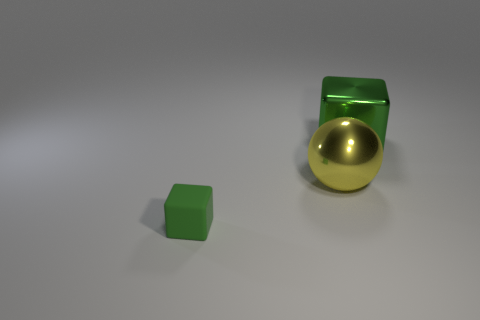There is a tiny matte object; is its color the same as the block right of the small block?
Keep it short and to the point. Yes. Is the color of the cube that is right of the small green rubber thing the same as the tiny matte object?
Make the answer very short. Yes. Are there more tiny objects than blocks?
Your response must be concise. No. Does the big yellow ball have the same material as the big block?
Provide a short and direct response. Yes. Is there any other thing that has the same material as the small thing?
Your answer should be compact. No. Is the number of tiny rubber objects that are in front of the big green object greater than the number of tiny blue metallic cylinders?
Ensure brevity in your answer.  Yes. Is the tiny thing the same color as the large shiny block?
Your response must be concise. Yes. What number of large metallic objects have the same shape as the small matte thing?
Ensure brevity in your answer.  1. What size is the green block that is the same material as the ball?
Keep it short and to the point. Large. There is a object that is left of the big green metallic cube and on the right side of the tiny green rubber object; what is its color?
Ensure brevity in your answer.  Yellow. 